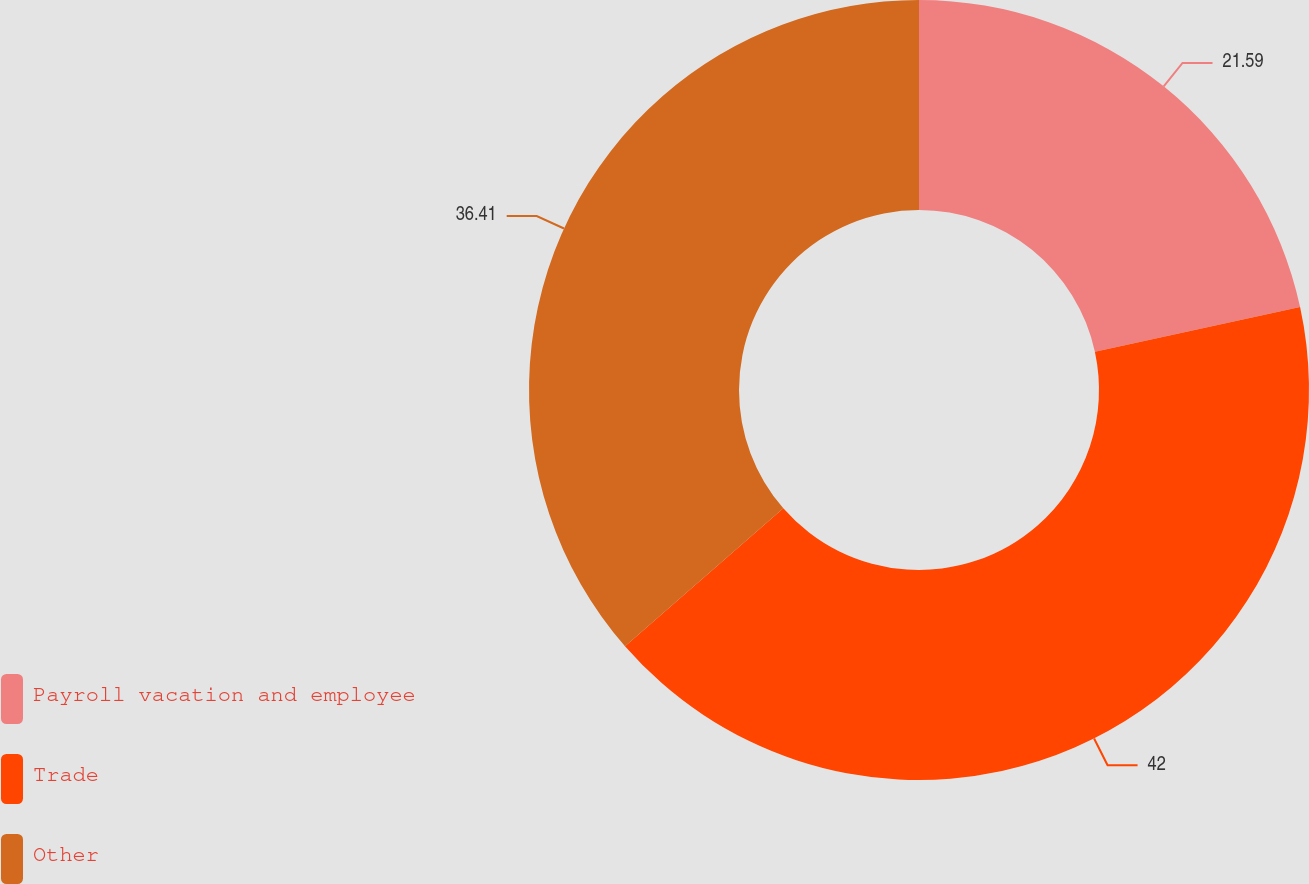<chart> <loc_0><loc_0><loc_500><loc_500><pie_chart><fcel>Payroll vacation and employee<fcel>Trade<fcel>Other<nl><fcel>21.59%<fcel>42.0%<fcel>36.41%<nl></chart> 